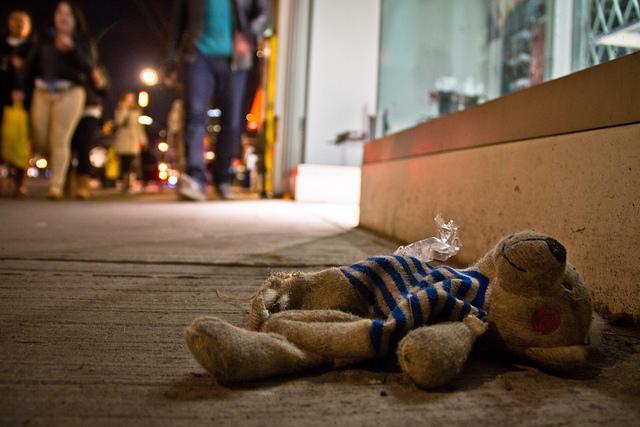How many bears?
Give a very brief answer. 1. How many people are there?
Give a very brief answer. 4. 